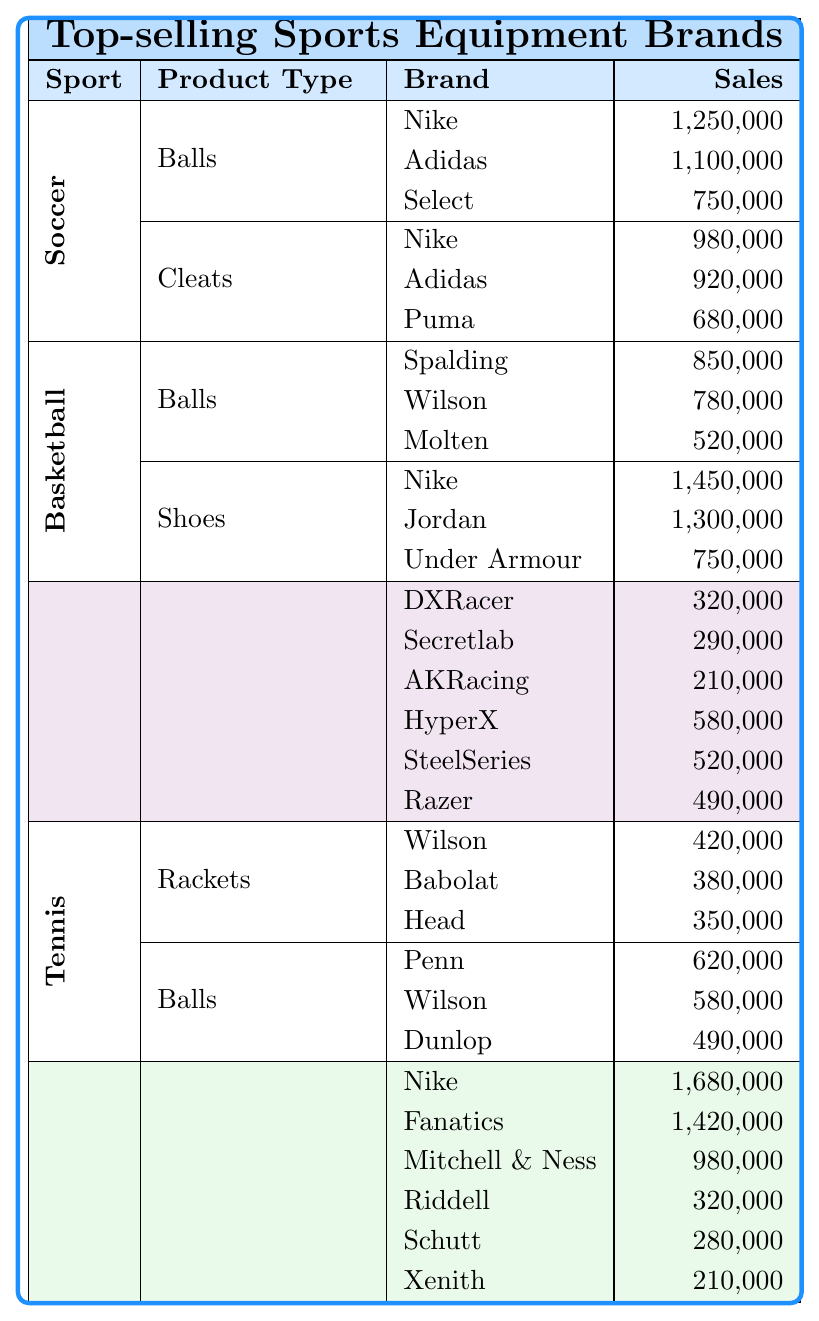What brand had the highest sales in soccer balls? The highest sales in soccer balls can be found by comparing the sales figures for all brands listed under the "Balls" category for soccer. Nike has sales of 1,250,000, Adidas has 1,100,000, and Select has 750,000. The highest is Nike with 1,250,000.
Answer: Nike Which sport has the lowest total sales for all product types? To find the sport with the lowest total sales, we need to calculate the total sales for each sport by adding the sales of all product types. After calculations, eSports has total sales of 1,400,000 (Gaming Chairs = 320,000 + Gaming Headsets = 580,000) which is less than the other sports.
Answer: eSports Did Adidas sell more in soccer cleats than Puma? We look at the sales figures for cleats under the soccer category. Adidas has sales of 920,000 while Puma has sales of 680,000. Since 920,000 is greater than 680,000, the statement is true.
Answer: Yes What is the total sales for Nike across all sports? First, we gather Nike's sales figures from all sports: Soccer balls (1,250,000), Soccer cleats (980,000), Basketball shoes (1,450,000), NFL jerseys (1,680,000). Then we sum them up: 1,250,000 + 980,000 + 1,450,000 + 1,680,000 = 5,360,000.
Answer: 5,360,000 Which brand in NFL helmets has the lowest sales? To determine the brand with the lowest sales for NFL helmets, we review the sales figures provided: Riddell has 320,000, Schutt has 280,000, and Xenith has 210,000. The lowest is Xenith with 210,000.
Answer: Xenith What is the average sales of basketball shoes among the top three brands? We first identify the sales figures for the top three basketball shoe brands: Nike (1,450,000), Jordan (1,300,000), and Under Armour (750,000). Their total is 1,450,000 + 1,300,000 + 750,000 = 3,500,000. The average is calculated by dividing this total by the number of brands (3): 3,500,000 / 3 = 1,166,666.67.
Answer: 1,166,666.67 Is it true that Wilson sold more tennis balls than racket sales combined? First, we gather Wilson's sales for tennis balls (580,000) and add the sales figures for tennis rackets (420,000 + 380,000 + 350,000) to find the total for rackets: 420,000 + 380,000 + 350,000 = 1,150,000. Since 580,000 is less than 1,150,000, the statement is false.
Answer: No Which sport has the highest total sales from all product types combined? We calculate the total sales for each sport: Soccer = 3,130,000, Basketball = 3,580,000, eSports = 1,400,000, Tennis = 1,690,000, NFL = 2,620,000. The sport with the highest total is Basketball with 3,580,000.
Answer: Basketball 